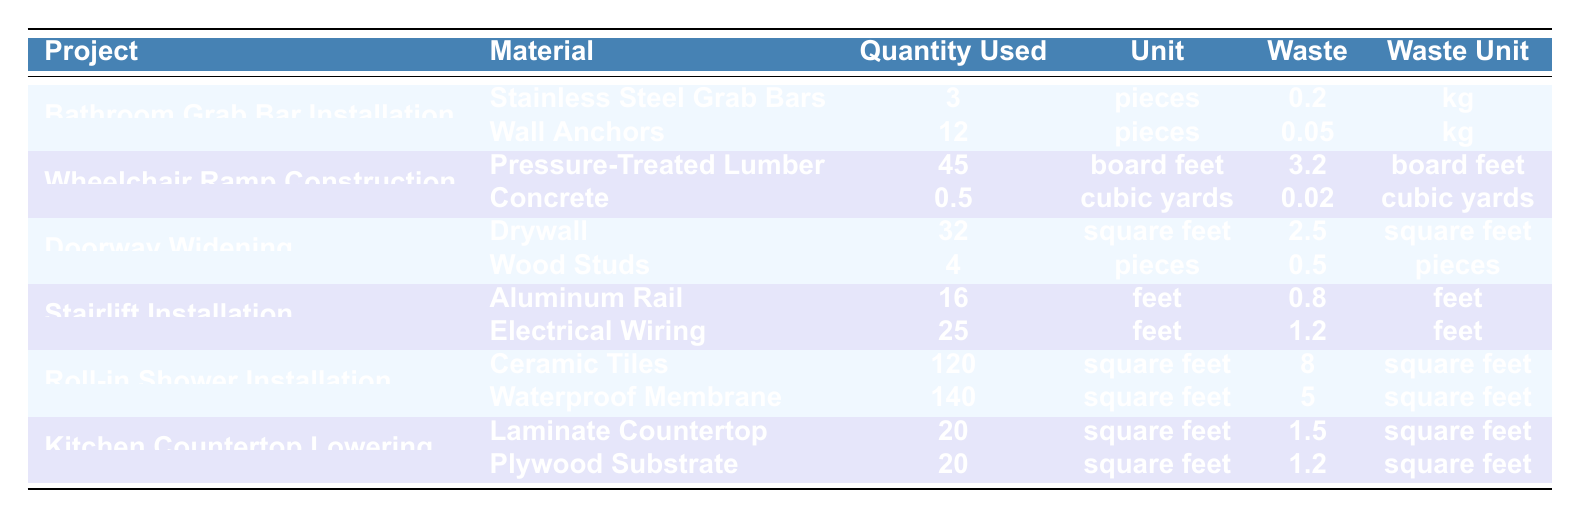What materials were used in the Bathroom Grab Bar Installation project? The table shows two materials used for the Bathroom Grab Bar Installation: Stainless Steel Grab Bars and Wall Anchors.
Answer: Stainless Steel Grab Bars, Wall Anchors How much waste was generated from the installation of Aluminum Rail for the Stairlift Installation? The table specifies that the waste generated from the Aluminum Rail in the Stairlift Installation project is 0.8 feet.
Answer: 0.8 feet What is the total amount of waste from materials used in the Roll-in Shower Installation? To find the total waste, we sum the waste for Ceramic Tiles (8 square feet) and Waterproof Membrane (5 square feet): 8 + 5 = 13 square feet.
Answer: 13 square feet Did the Doorway Widening project use more pieces of drywall than wood studs? The table shows that the quantity used for drywall is 32 pieces, while wood studs used is 4 pieces. Since 32 is greater than 4, the statement is true.
Answer: Yes What is the total quantity of materials used in the Kitchen Countertop Lowering project, and what is the average quantity per material? The total quantity is the sum of the laminate countertop (20 square feet) and plywood substrate (20 square feet): 20 + 20 = 40 square feet. The average per material is 40 / 2 = 20 square feet.
Answer: Total: 40 square feet; Average: 20 square feet Which project had the highest single quantity of waste, and what was that amount? Examining the waste quantities across all projects, the Roll-in Shower Installation produced 8 square feet from the Ceramic Tiles, which is the highest single waste amount.
Answer: Roll-in Shower Installation; 8 square feet How does the quantity of pressure-treated lumber used in the Wheelchair Ramp Construction compare to the quantity of pieces of wood studs used in the Doorway Widening project? The quantity of pressure-treated lumber used is 45 board feet, while the quantity of wood studs used is 4 pieces. Since 45 is greater than 4, pressure-treated lumber is used in a significantly larger quantity.
Answer: Greater quantity What was the total quantity of waste produced for all projects combined? To find the total waste, we add the waste amounts for all projects: 0.2 + 0.05 + 3.2 + 0.02 + 2.5 + 0.5 + 0.8 + 1.2 + 8 + 5 + 1.5 + 1.2 = 24.54.
Answer: 24.54 Compare the waste from the Waterproof Membrane to the waste from Wall Anchors. Which is more? The waste from Waterproof Membrane is 5 square feet, while the waste from Wall Anchors is 0.05 kg (approximately 0.05 square feet if assessed). Thus, 5 square feet is significantly more than 0.05.
Answer: Waterproof Membrane has more waste What percentage of the total quantity used in Bathroom Grab Bar Installation is attributed to the Wall Anchors? The total quantity used for the Bathroom Grab Bar Installation is 3 (Grab Bars) + 12 (Wall Anchors) = 15. The quantity of Wall Anchors is 12, so the percentage is (12 / 15) * 100 = 80%.
Answer: 80% 